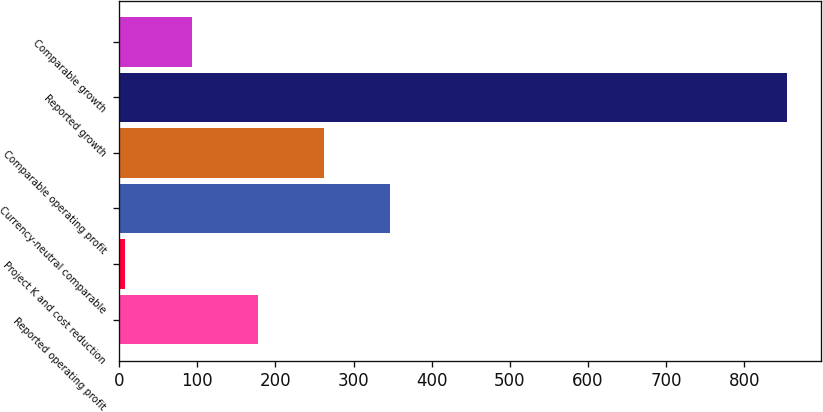Convert chart. <chart><loc_0><loc_0><loc_500><loc_500><bar_chart><fcel>Reported operating profit<fcel>Project K and cost reduction<fcel>Currency-neutral comparable<fcel>Comparable operating profit<fcel>Reported growth<fcel>Comparable growth<nl><fcel>177.44<fcel>8<fcel>346.88<fcel>262.16<fcel>855.2<fcel>92.72<nl></chart> 